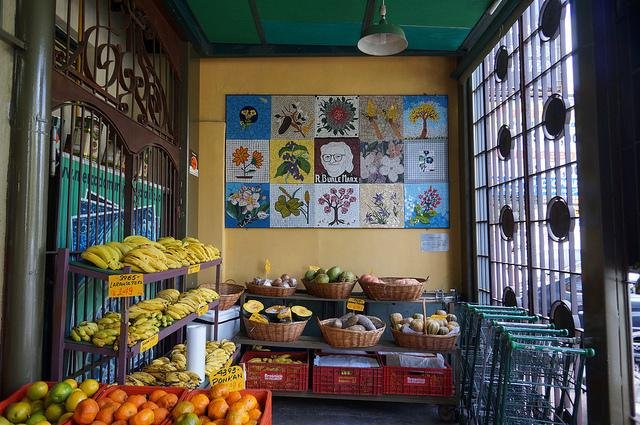Why are the fruits in the basket? Please explain your reasoning. to sell. The set up with this variety of fruit, the price tags visible throughout, the plastic produce bags and the grocery carts are all elements of a grocery store. a display like this at a grocery store would be to sell the fruit. 